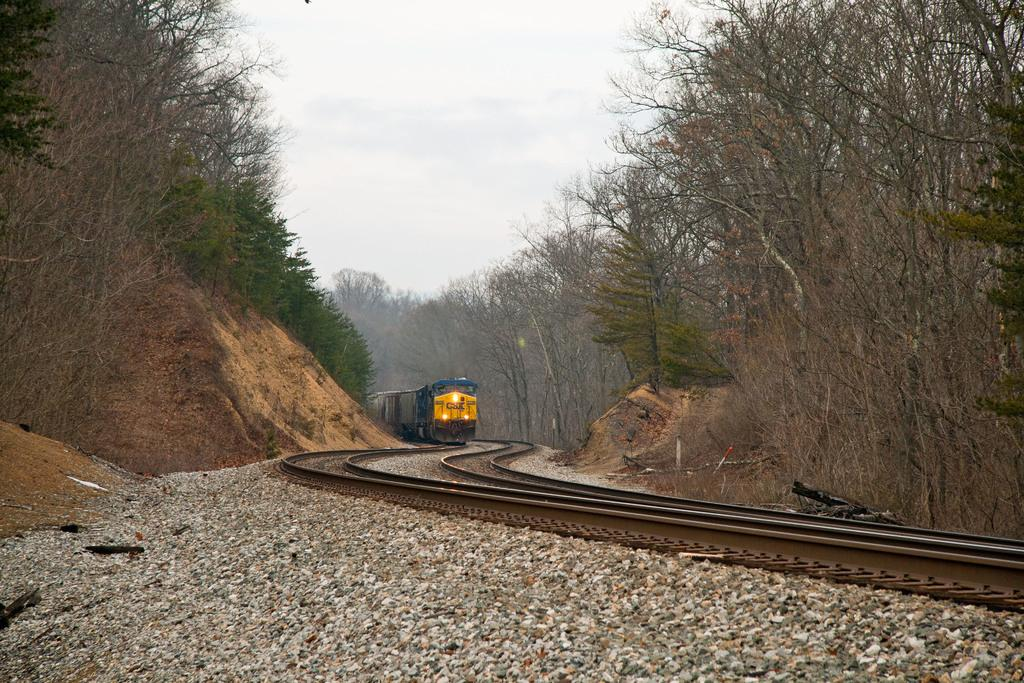What is the main subject of the picture? The main subject of the picture is a train. What is the train doing in the picture? The train is moving on a track. What can be seen on both sides of the picture? There are trees on both the left and right sides of the picture. What is visible in the background of the picture? The sky is clear and visible in the background of the picture. Can you tell me how many pears are on the train in the image? There are no pears present on the train in the image. Is there a woman standing next to the train in the image? There is no woman visible in the image; it only features a train moving on a track. 